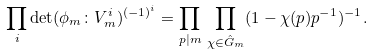Convert formula to latex. <formula><loc_0><loc_0><loc_500><loc_500>\prod _ { i } \det ( \phi _ { m } \colon V ^ { i } _ { m } ) ^ { ( - 1 ) ^ { i } } = \prod _ { p | m } \, \prod _ { \chi \in \hat { G } _ { m } } ( 1 - \chi ( p ) p ^ { - 1 } ) ^ { - 1 } .</formula> 